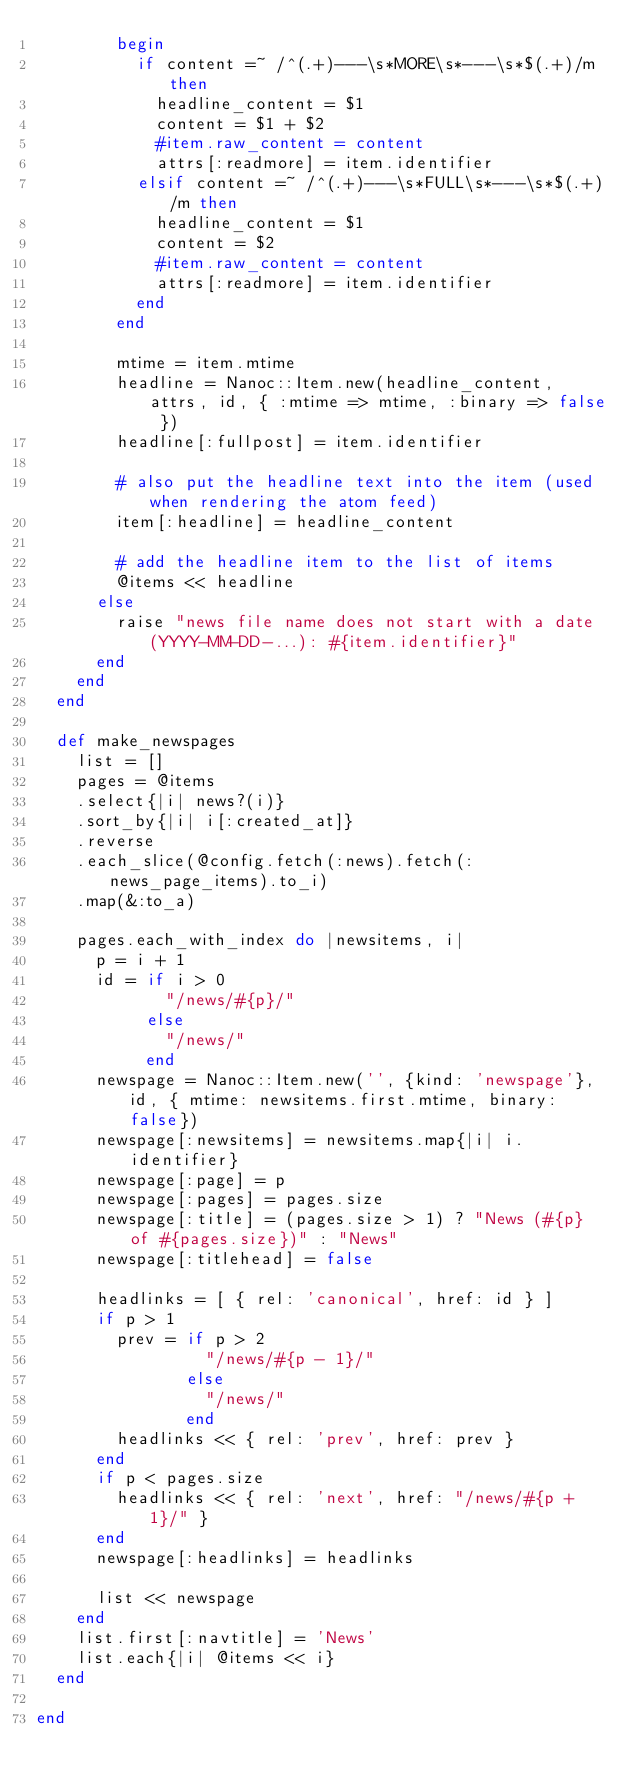Convert code to text. <code><loc_0><loc_0><loc_500><loc_500><_Ruby_>        begin
          if content =~ /^(.+)---\s*MORE\s*---\s*$(.+)/m then
            headline_content = $1
            content = $1 + $2
            #item.raw_content = content
            attrs[:readmore] = item.identifier
          elsif content =~ /^(.+)---\s*FULL\s*---\s*$(.+)/m then
            headline_content = $1
            content = $2
            #item.raw_content = content
            attrs[:readmore] = item.identifier
          end
        end

        mtime = item.mtime
        headline = Nanoc::Item.new(headline_content, attrs, id, { :mtime => mtime, :binary => false })
        headline[:fullpost] = item.identifier

        # also put the headline text into the item (used when rendering the atom feed)
        item[:headline] = headline_content

        # add the headline item to the list of items
        @items << headline
      else
        raise "news file name does not start with a date (YYYY-MM-DD-...): #{item.identifier}"
      end
    end
  end

  def make_newspages
    list = []
    pages = @items
    .select{|i| news?(i)}
    .sort_by{|i| i[:created_at]}
    .reverse
    .each_slice(@config.fetch(:news).fetch(:news_page_items).to_i)
    .map(&:to_a)

    pages.each_with_index do |newsitems, i|
      p = i + 1
      id = if i > 0
             "/news/#{p}/"
           else
             "/news/"
           end
      newspage = Nanoc::Item.new('', {kind: 'newspage'}, id, { mtime: newsitems.first.mtime, binary: false})
      newspage[:newsitems] = newsitems.map{|i| i.identifier}
      newspage[:page] = p
      newspage[:pages] = pages.size
      newspage[:title] = (pages.size > 1) ? "News (#{p} of #{pages.size})" : "News"
      newspage[:titlehead] = false

      headlinks = [ { rel: 'canonical', href: id } ]
      if p > 1
        prev = if p > 2
                 "/news/#{p - 1}/"
               else
                 "/news/"
               end
        headlinks << { rel: 'prev', href: prev }
      end
      if p < pages.size
        headlinks << { rel: 'next', href: "/news/#{p + 1}/" }
      end
      newspage[:headlinks] = headlinks

      list << newspage
    end
    list.first[:navtitle] = 'News'
    list.each{|i| @items << i}
  end

end
</code> 